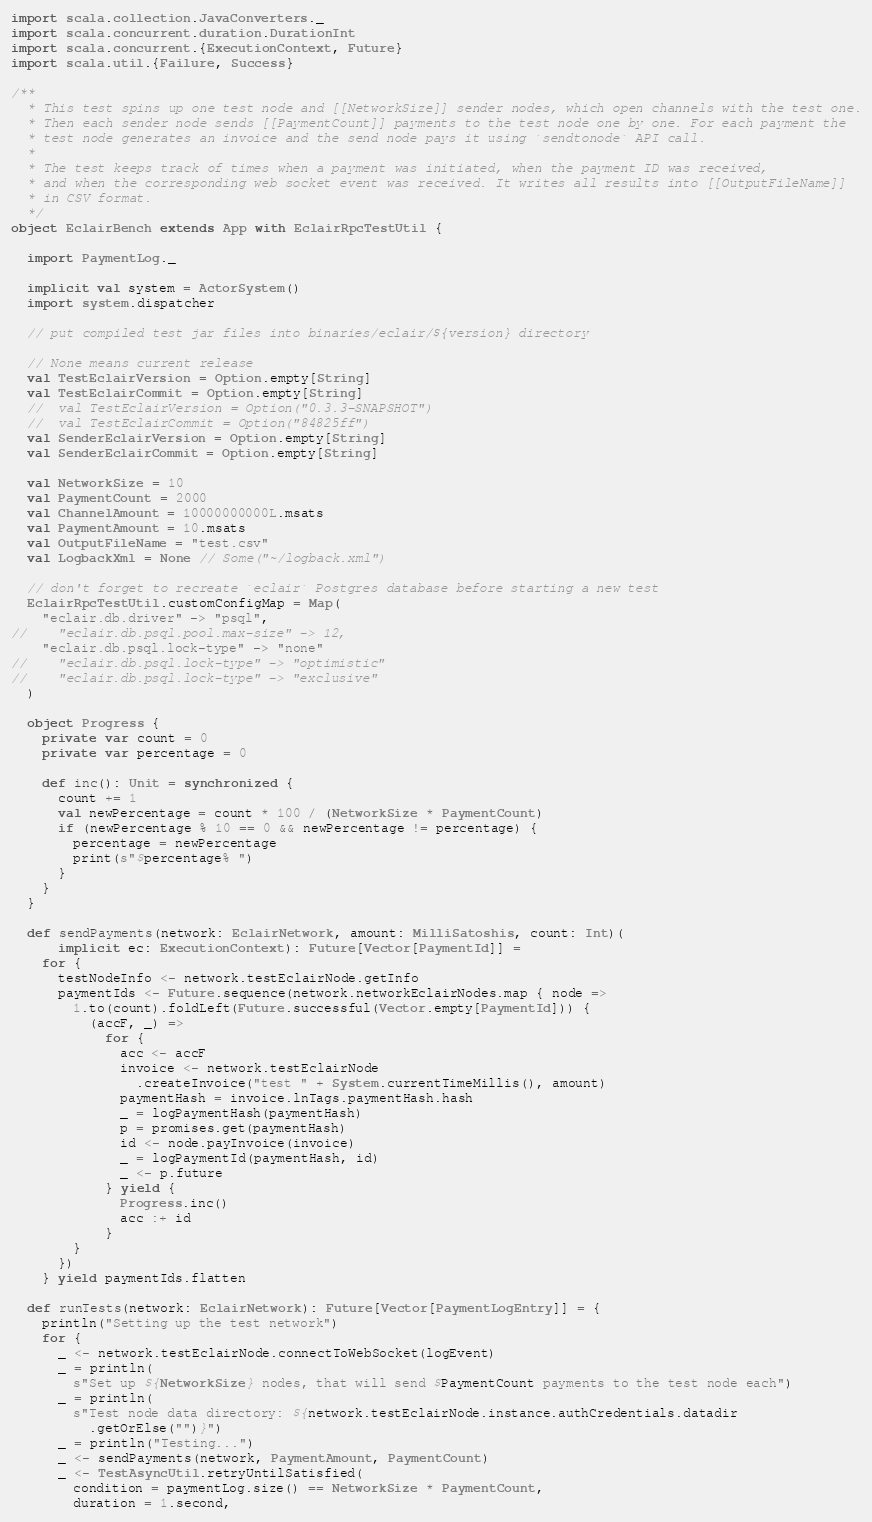<code> <loc_0><loc_0><loc_500><loc_500><_Scala_>
import scala.collection.JavaConverters._
import scala.concurrent.duration.DurationInt
import scala.concurrent.{ExecutionContext, Future}
import scala.util.{Failure, Success}

/**
  * This test spins up one test node and [[NetworkSize]] sender nodes, which open channels with the test one.
  * Then each sender node sends [[PaymentCount]] payments to the test node one by one. For each payment the
  * test node generates an invoice and the send node pays it using `sendtonode` API call.
  *
  * The test keeps track of times when a payment was initiated, when the payment ID was received,
  * and when the corresponding web socket event was received. It writes all results into [[OutputFileName]]
  * in CSV format.
  */
object EclairBench extends App with EclairRpcTestUtil {

  import PaymentLog._

  implicit val system = ActorSystem()
  import system.dispatcher

  // put compiled test jar files into binaries/eclair/${version} directory

  // None means current release
  val TestEclairVersion = Option.empty[String]
  val TestEclairCommit = Option.empty[String]
  //  val TestEclairVersion = Option("0.3.3-SNAPSHOT")
  //  val TestEclairCommit = Option("84825ff")
  val SenderEclairVersion = Option.empty[String]
  val SenderEclairCommit = Option.empty[String]

  val NetworkSize = 10
  val PaymentCount = 2000
  val ChannelAmount = 10000000000L.msats
  val PaymentAmount = 10.msats
  val OutputFileName = "test.csv"
  val LogbackXml = None // Some("~/logback.xml")

  // don't forget to recreate `eclair` Postgres database before starting a new test
  EclairRpcTestUtil.customConfigMap = Map(
    "eclair.db.driver" -> "psql",
//    "eclair.db.psql.pool.max-size" -> 12,
    "eclair.db.psql.lock-type" -> "none"
//    "eclair.db.psql.lock-type" -> "optimistic"
//    "eclair.db.psql.lock-type" -> "exclusive"
  )

  object Progress {
    private var count = 0
    private var percentage = 0

    def inc(): Unit = synchronized {
      count += 1
      val newPercentage = count * 100 / (NetworkSize * PaymentCount)
      if (newPercentage % 10 == 0 && newPercentage != percentage) {
        percentage = newPercentage
        print(s"$percentage% ")
      }
    }
  }

  def sendPayments(network: EclairNetwork, amount: MilliSatoshis, count: Int)(
      implicit ec: ExecutionContext): Future[Vector[PaymentId]] =
    for {
      testNodeInfo <- network.testEclairNode.getInfo
      paymentIds <- Future.sequence(network.networkEclairNodes.map { node =>
        1.to(count).foldLeft(Future.successful(Vector.empty[PaymentId])) {
          (accF, _) =>
            for {
              acc <- accF
              invoice <- network.testEclairNode
                .createInvoice("test " + System.currentTimeMillis(), amount)
              paymentHash = invoice.lnTags.paymentHash.hash
              _ = logPaymentHash(paymentHash)
              p = promises.get(paymentHash)
              id <- node.payInvoice(invoice)
              _ = logPaymentId(paymentHash, id)
              _ <- p.future
            } yield {
              Progress.inc()
              acc :+ id
            }
        }
      })
    } yield paymentIds.flatten

  def runTests(network: EclairNetwork): Future[Vector[PaymentLogEntry]] = {
    println("Setting up the test network")
    for {
      _ <- network.testEclairNode.connectToWebSocket(logEvent)
      _ = println(
        s"Set up ${NetworkSize} nodes, that will send $PaymentCount payments to the test node each")
      _ = println(
        s"Test node data directory: ${network.testEclairNode.instance.authCredentials.datadir
          .getOrElse("")}")
      _ = println("Testing...")
      _ <- sendPayments(network, PaymentAmount, PaymentCount)
      _ <- TestAsyncUtil.retryUntilSatisfied(
        condition = paymentLog.size() == NetworkSize * PaymentCount,
        duration = 1.second,</code> 